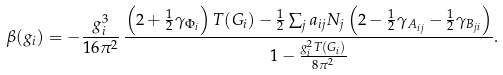<formula> <loc_0><loc_0><loc_500><loc_500>\beta ( g _ { i } ) = - \frac { g _ { i } ^ { 3 } } { 1 6 \pi ^ { 2 } } \, \frac { \left ( 2 + \frac { 1 } { 2 } \gamma _ { \Phi _ { i } } \right ) T ( G _ { i } ) - \frac { 1 } { 2 } \sum _ { j } a _ { i j } N _ { j } \left ( 2 - \frac { 1 } { 2 } \gamma _ { A _ { i j } } - \frac { 1 } { 2 } \gamma _ { B _ { j i } } \right ) } { 1 - \frac { g _ { i } ^ { 2 } T ( G _ { i } ) } { 8 \pi ^ { 2 } } } .</formula> 